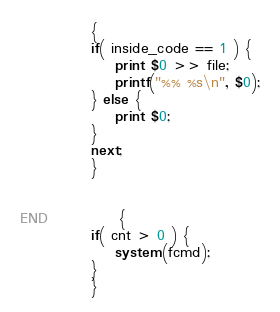<code> <loc_0><loc_0><loc_500><loc_500><_Awk_>
		    {
			if( inside_code == 1 ) {
			    print $0 >> file;
			    printf("%% %s\n", $0);
			} else {
			    print $0;
			}
			next;
		    }


END		    {
			if( cnt > 0 ) {
			    system(fcmd);
			}
		    }
</code> 